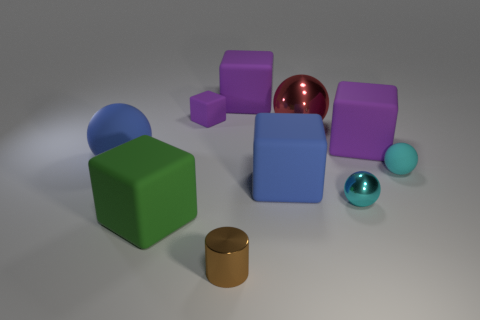What is the material of the other ball that is the same color as the tiny shiny sphere?
Offer a very short reply. Rubber. The tiny matte object that is the same shape as the big green rubber object is what color?
Ensure brevity in your answer.  Purple. There is a cube that is both on the left side of the tiny metallic cylinder and right of the green block; what material is it?
Ensure brevity in your answer.  Rubber. There is a shiny thing behind the cyan rubber sphere; does it have the same size as the cyan matte thing?
Keep it short and to the point. No. What material is the green object?
Offer a very short reply. Rubber. The small matte object left of the blue matte cube is what color?
Make the answer very short. Purple. How many large things are blue balls or rubber balls?
Provide a short and direct response. 1. Does the big matte cube on the left side of the small brown metal thing have the same color as the ball that is left of the small metal cylinder?
Give a very brief answer. No. What number of other objects are the same color as the small metal cylinder?
Offer a very short reply. 0. What number of yellow objects are metallic cylinders or small metal objects?
Offer a terse response. 0. 